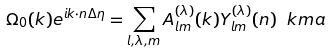<formula> <loc_0><loc_0><loc_500><loc_500>\Omega _ { 0 } ( k ) e ^ { i k \cdot n \Delta \eta } = \sum _ { l , \lambda , m } A ^ { ( \lambda ) } _ { l m } ( k ) Y ^ { ( \lambda ) } _ { l m } ( n ) \ k m a</formula> 